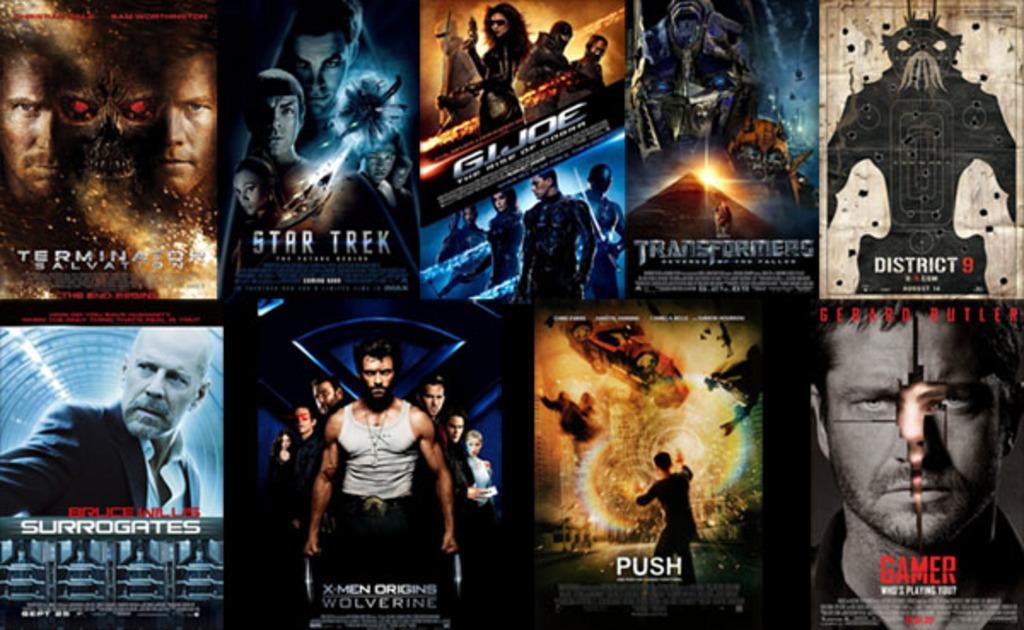Please provide a concise description of this image. In this picture I can see collage image. I can see people, names and some other things. 